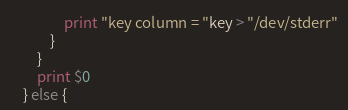Convert code to text. <code><loc_0><loc_0><loc_500><loc_500><_Awk_>				print "key column = "key > "/dev/stderr"
			}
		}
		print $0
	} else {</code> 